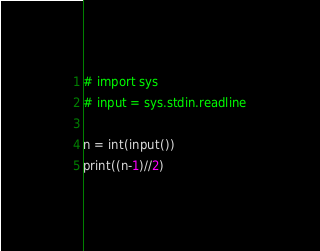Convert code to text. <code><loc_0><loc_0><loc_500><loc_500><_Python_># import sys
# input = sys.stdin.readline

n = int(input())
print((n-1)//2)</code> 